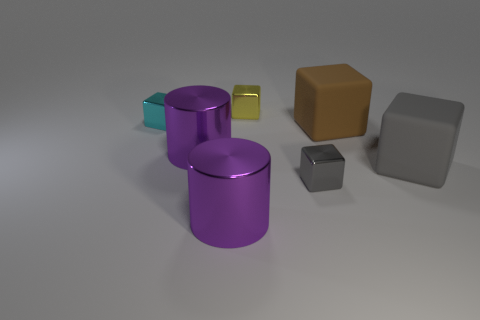Subtract 1 cubes. How many cubes are left? 4 Subtract all yellow cubes. How many cubes are left? 4 Subtract all large gray cubes. How many cubes are left? 4 Add 2 gray blocks. How many objects exist? 9 Subtract all purple cubes. Subtract all blue spheres. How many cubes are left? 5 Subtract all blocks. How many objects are left? 2 Add 3 yellow shiny cubes. How many yellow shiny cubes exist? 4 Subtract 0 purple cubes. How many objects are left? 7 Subtract all tiny things. Subtract all cyan shiny things. How many objects are left? 3 Add 3 big things. How many big things are left? 7 